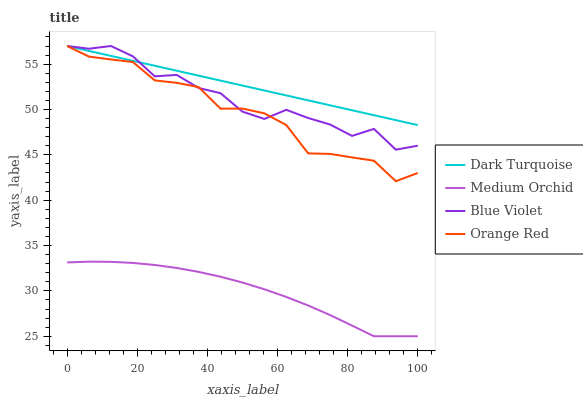Does Medium Orchid have the minimum area under the curve?
Answer yes or no. Yes. Does Dark Turquoise have the maximum area under the curve?
Answer yes or no. Yes. Does Orange Red have the minimum area under the curve?
Answer yes or no. No. Does Orange Red have the maximum area under the curve?
Answer yes or no. No. Is Dark Turquoise the smoothest?
Answer yes or no. Yes. Is Blue Violet the roughest?
Answer yes or no. Yes. Is Medium Orchid the smoothest?
Answer yes or no. No. Is Medium Orchid the roughest?
Answer yes or no. No. Does Medium Orchid have the lowest value?
Answer yes or no. Yes. Does Orange Red have the lowest value?
Answer yes or no. No. Does Blue Violet have the highest value?
Answer yes or no. Yes. Does Medium Orchid have the highest value?
Answer yes or no. No. Is Medium Orchid less than Dark Turquoise?
Answer yes or no. Yes. Is Orange Red greater than Medium Orchid?
Answer yes or no. Yes. Does Dark Turquoise intersect Blue Violet?
Answer yes or no. Yes. Is Dark Turquoise less than Blue Violet?
Answer yes or no. No. Is Dark Turquoise greater than Blue Violet?
Answer yes or no. No. Does Medium Orchid intersect Dark Turquoise?
Answer yes or no. No. 